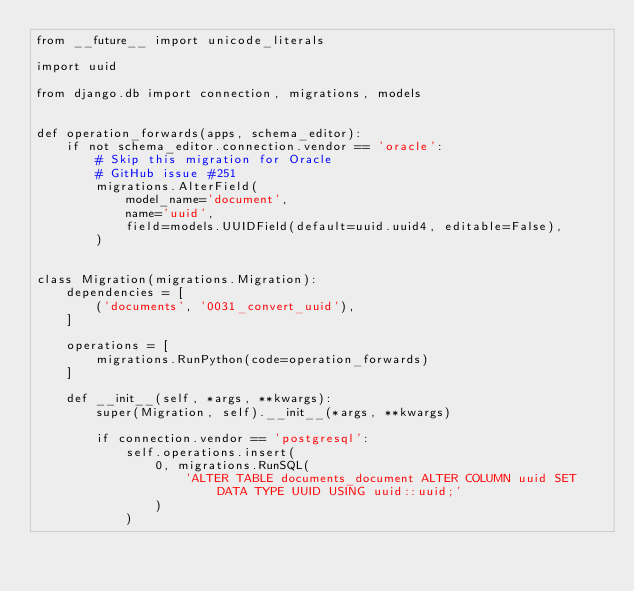Convert code to text. <code><loc_0><loc_0><loc_500><loc_500><_Python_>from __future__ import unicode_literals

import uuid

from django.db import connection, migrations, models


def operation_forwards(apps, schema_editor):
    if not schema_editor.connection.vendor == 'oracle':
        # Skip this migration for Oracle
        # GitHub issue #251
        migrations.AlterField(
            model_name='document',
            name='uuid',
            field=models.UUIDField(default=uuid.uuid4, editable=False),
        )


class Migration(migrations.Migration):
    dependencies = [
        ('documents', '0031_convert_uuid'),
    ]

    operations = [
        migrations.RunPython(code=operation_forwards)
    ]

    def __init__(self, *args, **kwargs):
        super(Migration, self).__init__(*args, **kwargs)

        if connection.vendor == 'postgresql':
            self.operations.insert(
                0, migrations.RunSQL(
                    'ALTER TABLE documents_document ALTER COLUMN uuid SET DATA TYPE UUID USING uuid::uuid;'
                )
            )
</code> 